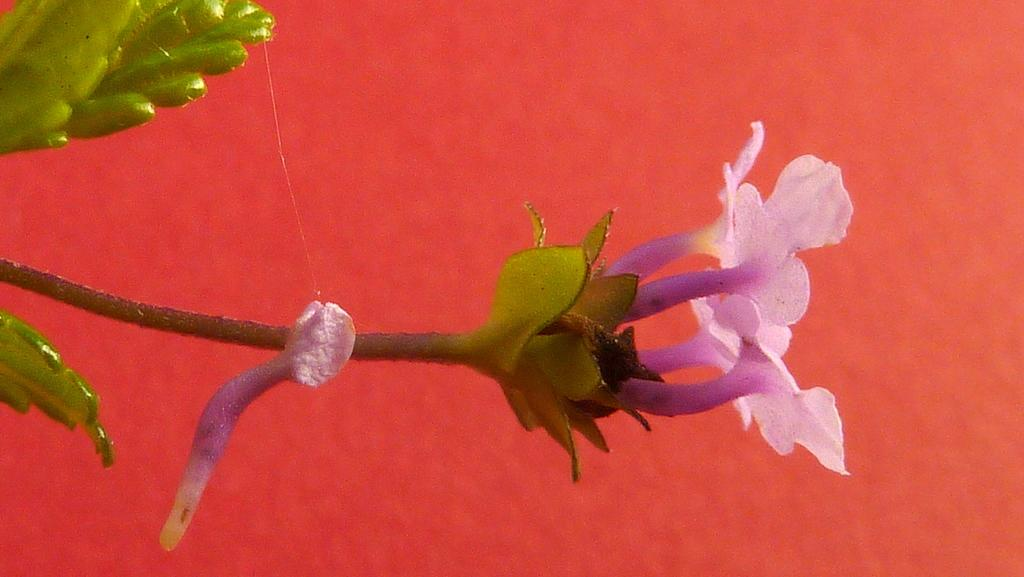What type of flora is present in the image? There are flowers in the image. What color are the flowers? The flowers are pink in color. What other plant is visible in the image? There is a tree in the image. What color is the tree? The tree is green in color. What colors can be seen in the background of the image? The background of the image has orange and red colors. Can you hear the voice of the flowers in the image? There is no voice present in the image, as flowers are not capable of producing sound. 